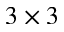Convert formula to latex. <formula><loc_0><loc_0><loc_500><loc_500>3 \times 3</formula> 